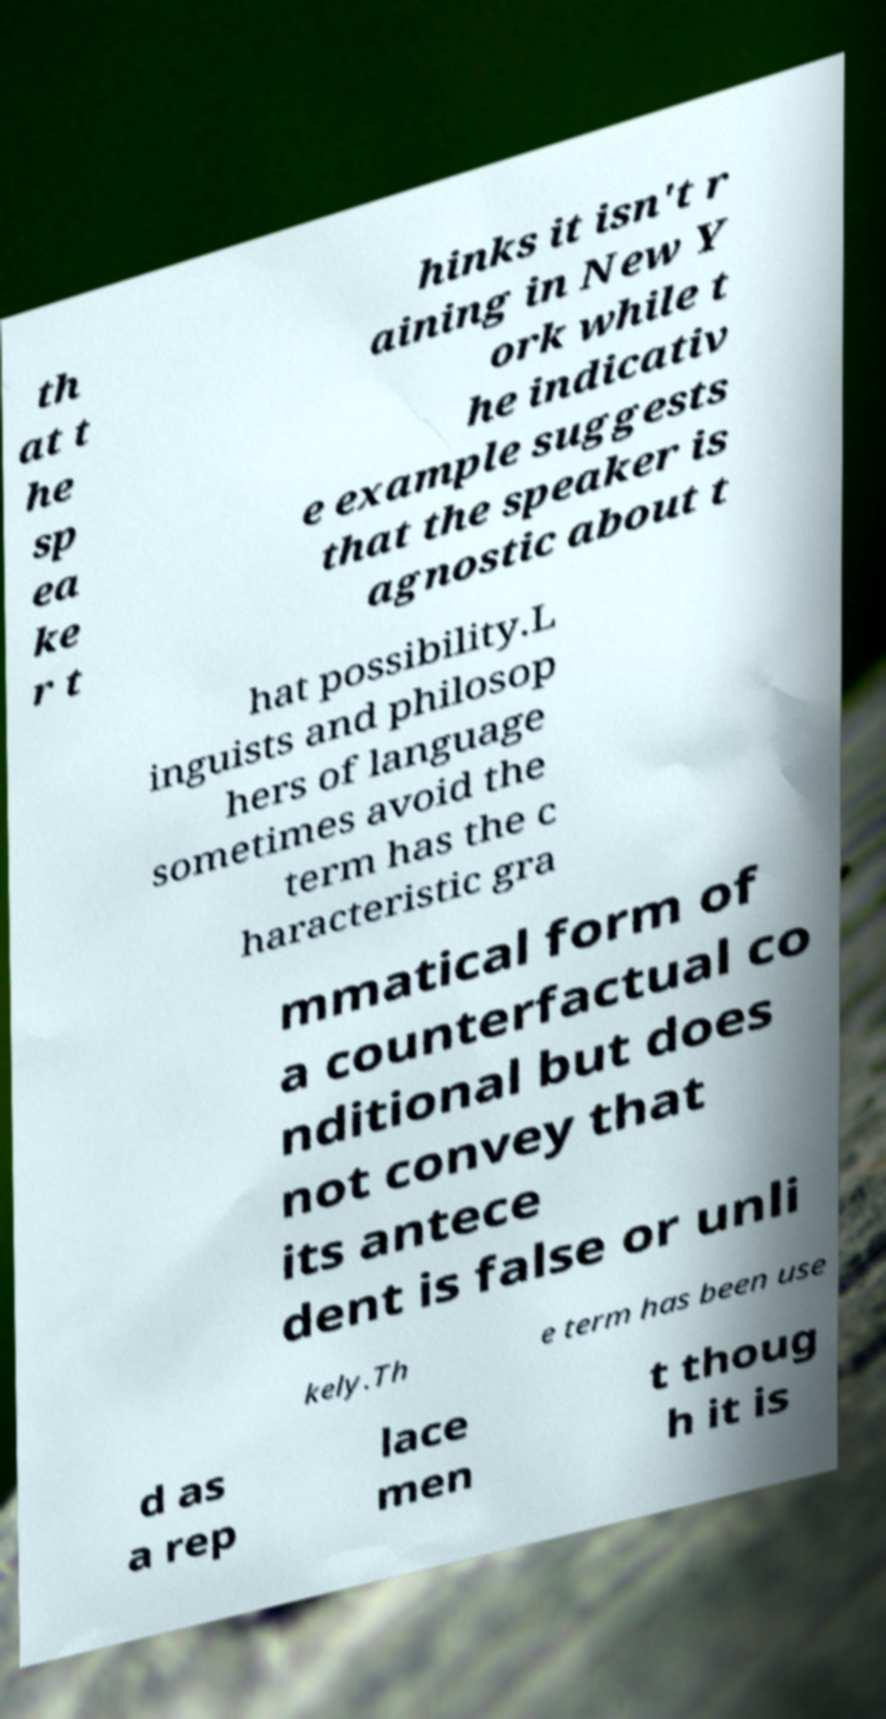Could you assist in decoding the text presented in this image and type it out clearly? th at t he sp ea ke r t hinks it isn't r aining in New Y ork while t he indicativ e example suggests that the speaker is agnostic about t hat possibility.L inguists and philosop hers of language sometimes avoid the term has the c haracteristic gra mmatical form of a counterfactual co nditional but does not convey that its antece dent is false or unli kely.Th e term has been use d as a rep lace men t thoug h it is 